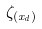<formula> <loc_0><loc_0><loc_500><loc_500>\zeta _ { ( x _ { d } ) }</formula> 